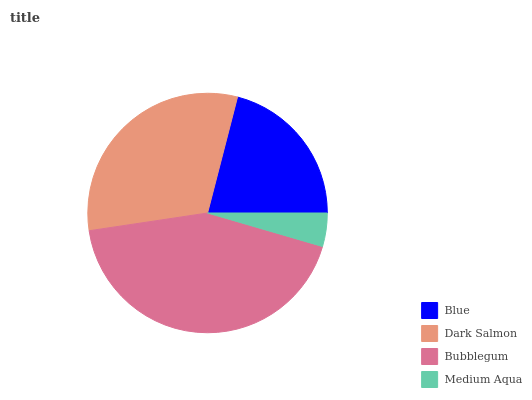Is Medium Aqua the minimum?
Answer yes or no. Yes. Is Bubblegum the maximum?
Answer yes or no. Yes. Is Dark Salmon the minimum?
Answer yes or no. No. Is Dark Salmon the maximum?
Answer yes or no. No. Is Dark Salmon greater than Blue?
Answer yes or no. Yes. Is Blue less than Dark Salmon?
Answer yes or no. Yes. Is Blue greater than Dark Salmon?
Answer yes or no. No. Is Dark Salmon less than Blue?
Answer yes or no. No. Is Dark Salmon the high median?
Answer yes or no. Yes. Is Blue the low median?
Answer yes or no. Yes. Is Medium Aqua the high median?
Answer yes or no. No. Is Bubblegum the low median?
Answer yes or no. No. 